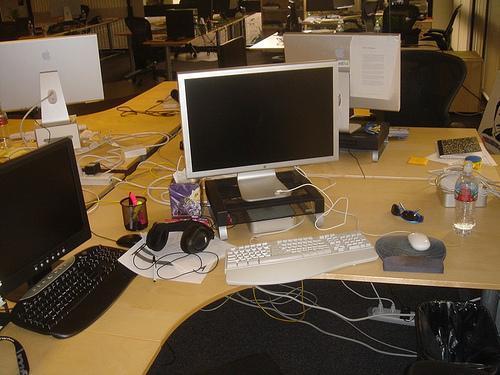How many chairs can you see?
Give a very brief answer. 1. How many keyboards are in the photo?
Give a very brief answer. 2. How many tvs are there?
Give a very brief answer. 2. 